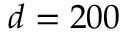<formula> <loc_0><loc_0><loc_500><loc_500>d = 2 0 0</formula> 